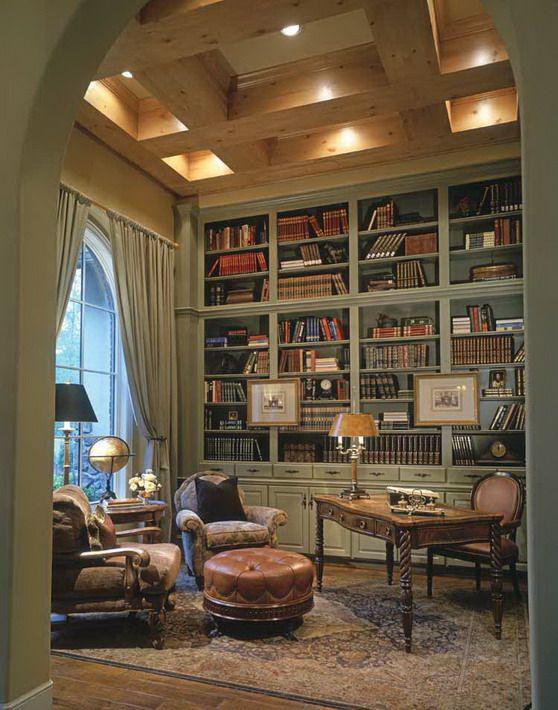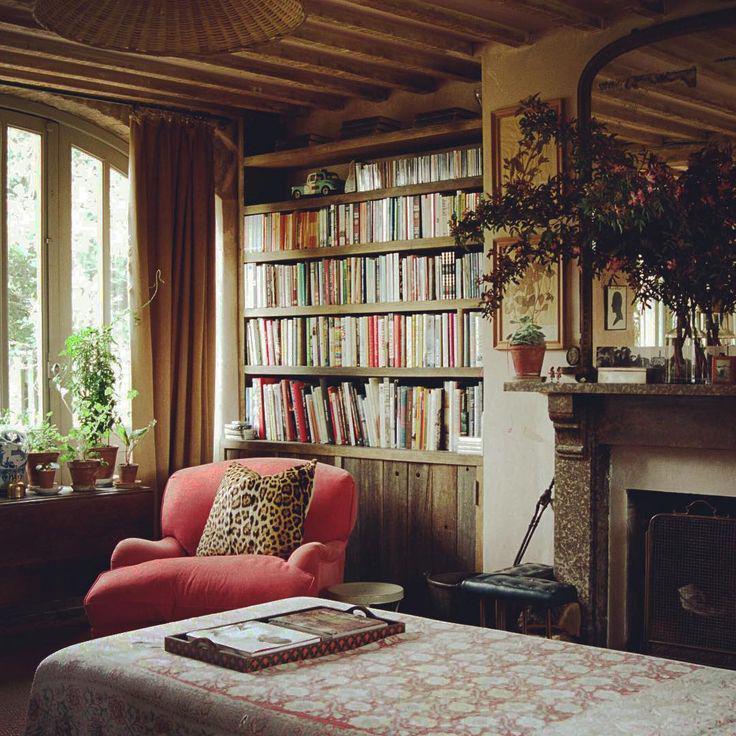The first image is the image on the left, the second image is the image on the right. Considering the images on both sides, is "There is a fireplace in at least one of the images." valid? Answer yes or no. Yes. The first image is the image on the left, the second image is the image on the right. Evaluate the accuracy of this statement regarding the images: "In at least one of the images there is a lamp suspended on a visible chain from the ceiling.". Is it true? Answer yes or no. No. 